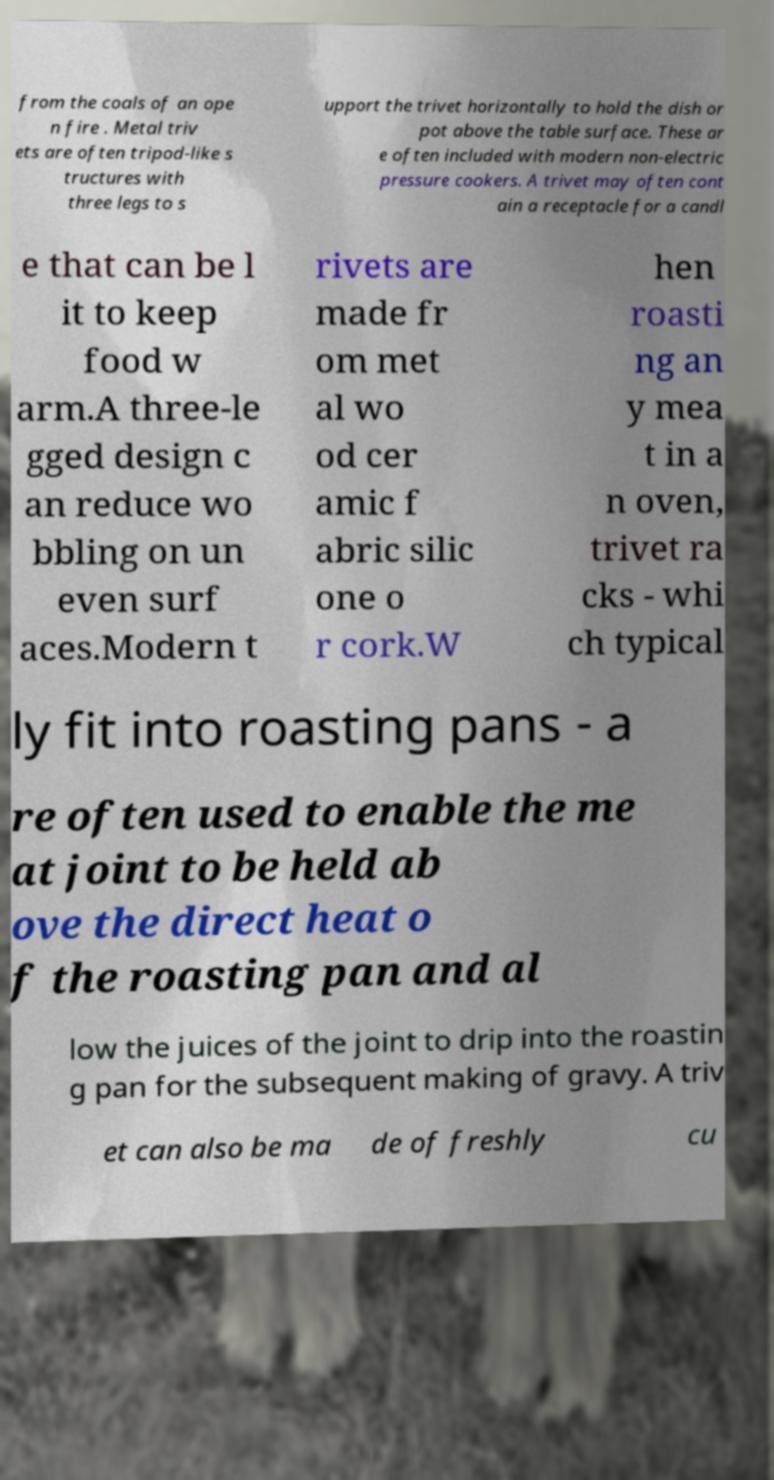There's text embedded in this image that I need extracted. Can you transcribe it verbatim? from the coals of an ope n fire . Metal triv ets are often tripod-like s tructures with three legs to s upport the trivet horizontally to hold the dish or pot above the table surface. These ar e often included with modern non-electric pressure cookers. A trivet may often cont ain a receptacle for a candl e that can be l it to keep food w arm.A three-le gged design c an reduce wo bbling on un even surf aces.Modern t rivets are made fr om met al wo od cer amic f abric silic one o r cork.W hen roasti ng an y mea t in a n oven, trivet ra cks - whi ch typical ly fit into roasting pans - a re often used to enable the me at joint to be held ab ove the direct heat o f the roasting pan and al low the juices of the joint to drip into the roastin g pan for the subsequent making of gravy. A triv et can also be ma de of freshly cu 